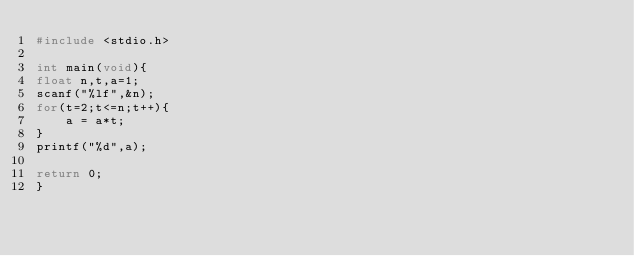<code> <loc_0><loc_0><loc_500><loc_500><_C_>#include <stdio.h>

int main(void){
float n,t,a=1;
scanf("%lf",&n);
for(t=2;t<=n;t++){
    a = a*t;
}
printf("%d",a);

return 0;
}</code> 